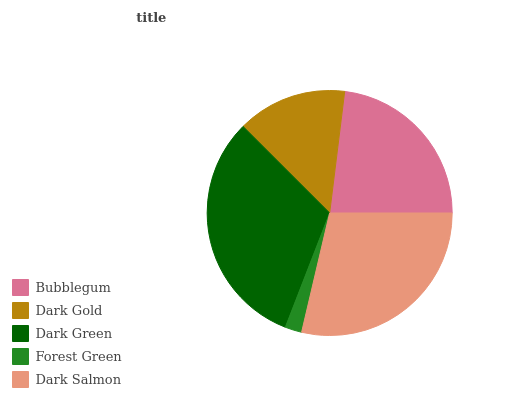Is Forest Green the minimum?
Answer yes or no. Yes. Is Dark Green the maximum?
Answer yes or no. Yes. Is Dark Gold the minimum?
Answer yes or no. No. Is Dark Gold the maximum?
Answer yes or no. No. Is Bubblegum greater than Dark Gold?
Answer yes or no. Yes. Is Dark Gold less than Bubblegum?
Answer yes or no. Yes. Is Dark Gold greater than Bubblegum?
Answer yes or no. No. Is Bubblegum less than Dark Gold?
Answer yes or no. No. Is Bubblegum the high median?
Answer yes or no. Yes. Is Bubblegum the low median?
Answer yes or no. Yes. Is Dark Salmon the high median?
Answer yes or no. No. Is Dark Green the low median?
Answer yes or no. No. 